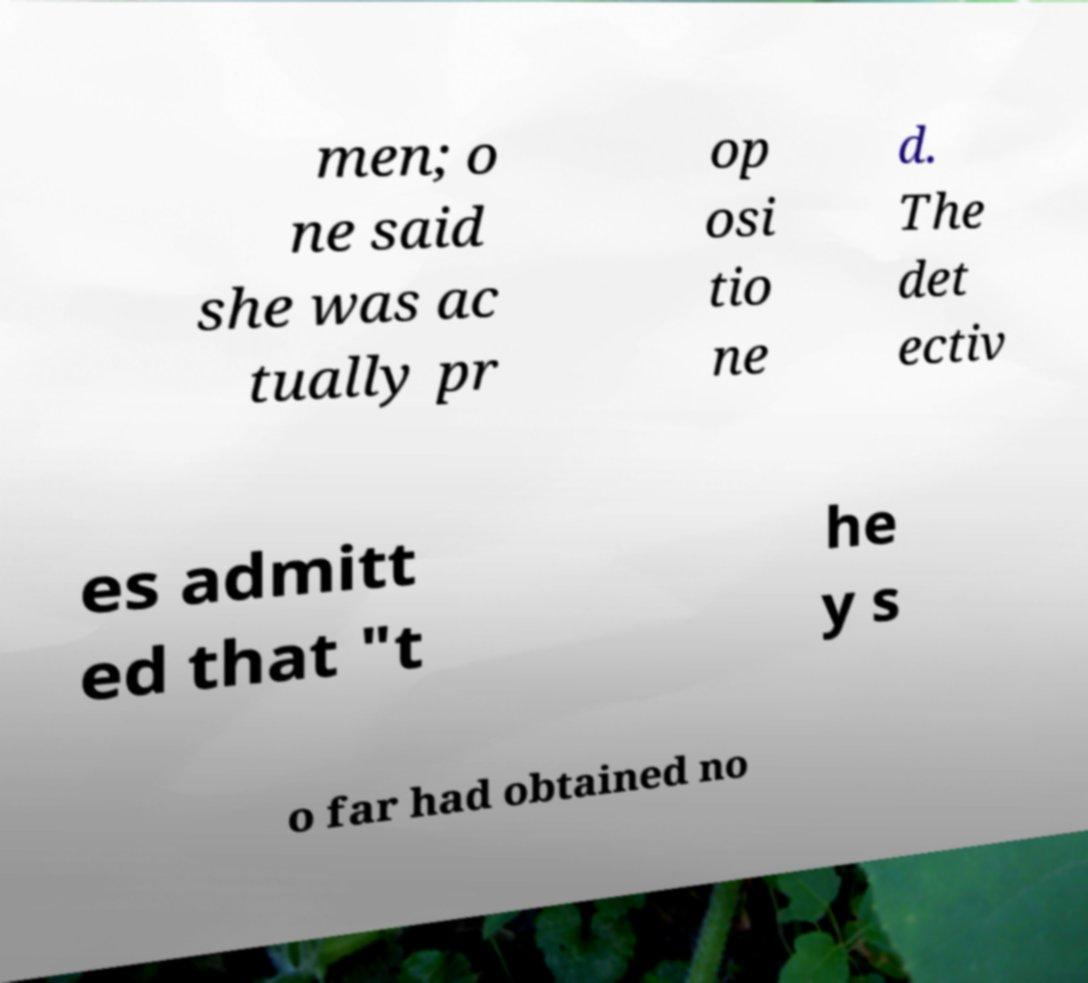Could you extract and type out the text from this image? men; o ne said she was ac tually pr op osi tio ne d. The det ectiv es admitt ed that "t he y s o far had obtained no 